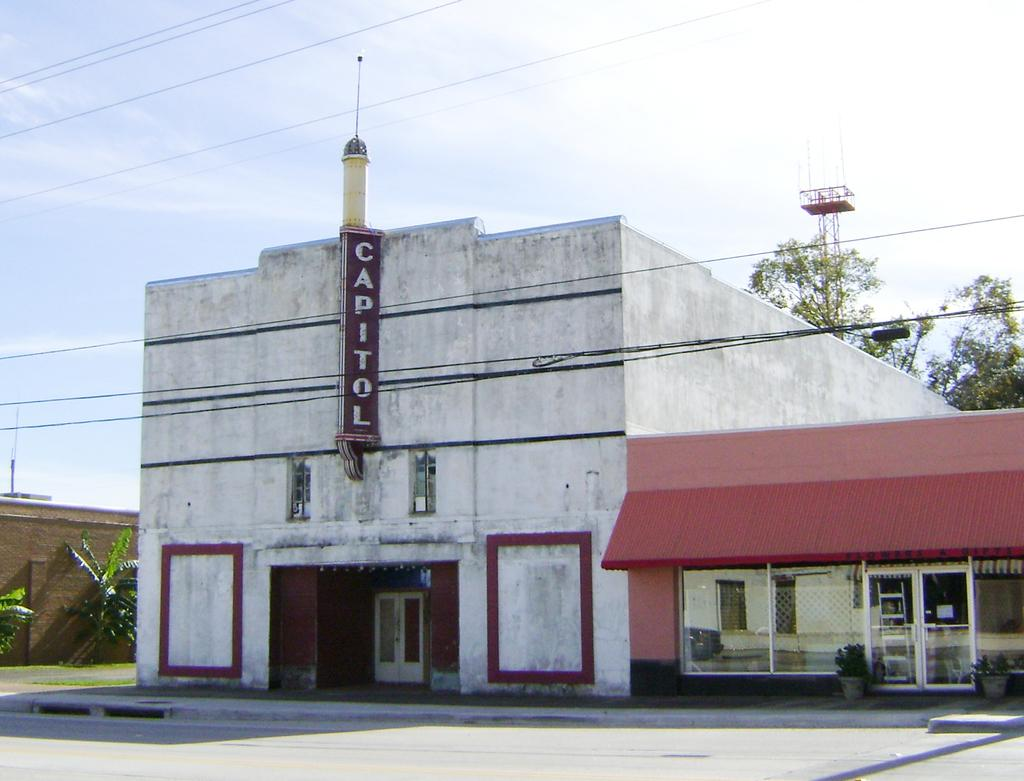What structures are located in the foreground of the image? There are two buildings in the foreground of the image. What features can be seen on the buildings? There are doors and glass windows visible on the buildings. What other objects are present in the image? Cables and trees are present in the image. What can be seen in the background of the image? The sky is visible in the image. What type of acoustics can be heard from the island in the image? There is no island present in the image, and therefore no acoustics can be heard from it. What is the smell of the trees in the image? The image does not convey any smells, so it is impossible to determine the smell of the trees. 